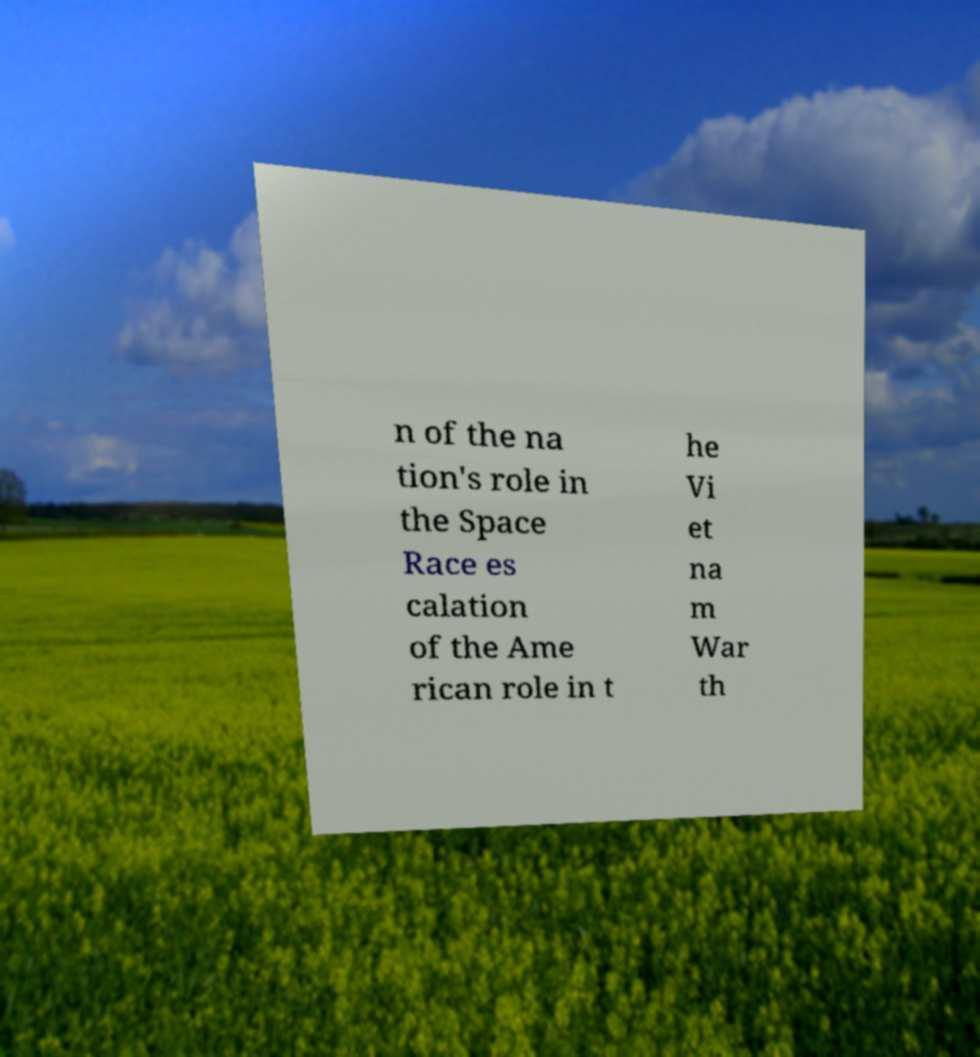For documentation purposes, I need the text within this image transcribed. Could you provide that? n of the na tion's role in the Space Race es calation of the Ame rican role in t he Vi et na m War th 